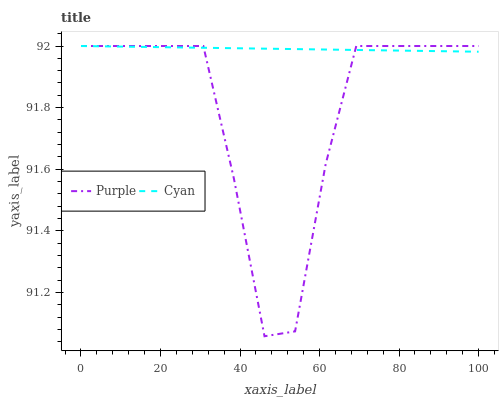Does Purple have the minimum area under the curve?
Answer yes or no. Yes. Does Cyan have the maximum area under the curve?
Answer yes or no. Yes. Does Cyan have the minimum area under the curve?
Answer yes or no. No. Is Cyan the smoothest?
Answer yes or no. Yes. Is Purple the roughest?
Answer yes or no. Yes. Is Cyan the roughest?
Answer yes or no. No. Does Purple have the lowest value?
Answer yes or no. Yes. Does Cyan have the lowest value?
Answer yes or no. No. Does Cyan have the highest value?
Answer yes or no. Yes. Does Cyan intersect Purple?
Answer yes or no. Yes. Is Cyan less than Purple?
Answer yes or no. No. Is Cyan greater than Purple?
Answer yes or no. No. 